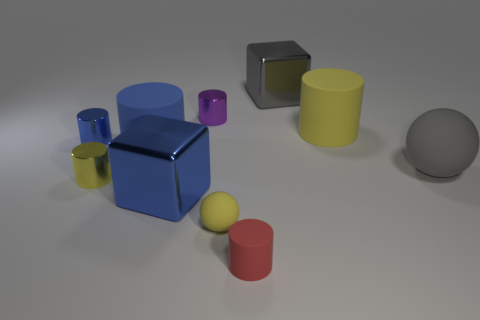Are there any large red metallic cubes?
Offer a terse response. No. Are there more tiny purple metallic cylinders right of the small red matte cylinder than cylinders that are on the right side of the blue shiny block?
Your response must be concise. No. There is a metallic cylinder that is to the right of the large metal block left of the small yellow ball; what is its color?
Give a very brief answer. Purple. Is there another small matte sphere that has the same color as the tiny matte ball?
Keep it short and to the point. No. What size is the yellow cylinder on the right side of the big block in front of the yellow matte thing that is behind the big gray rubber thing?
Make the answer very short. Large. The yellow shiny object is what shape?
Make the answer very short. Cylinder. There is a rubber thing that is the same color as the tiny sphere; what size is it?
Provide a succinct answer. Large. What number of large blue matte things are in front of the small thing that is on the right side of the tiny rubber ball?
Your answer should be very brief. 0. What number of other things are made of the same material as the big yellow thing?
Provide a short and direct response. 4. Does the sphere behind the yellow shiny cylinder have the same material as the small yellow thing behind the big blue metal thing?
Ensure brevity in your answer.  No. 